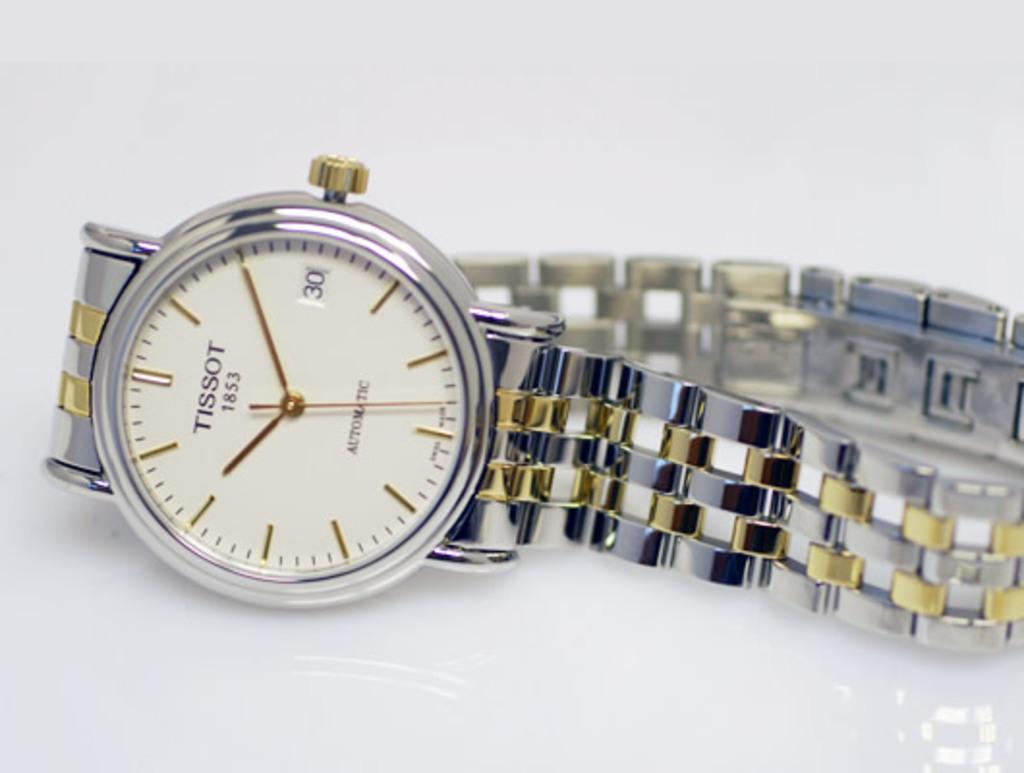Hey what time is it?
Provide a short and direct response. 10:10. What brand is the watch?
Give a very brief answer. Tissot. 